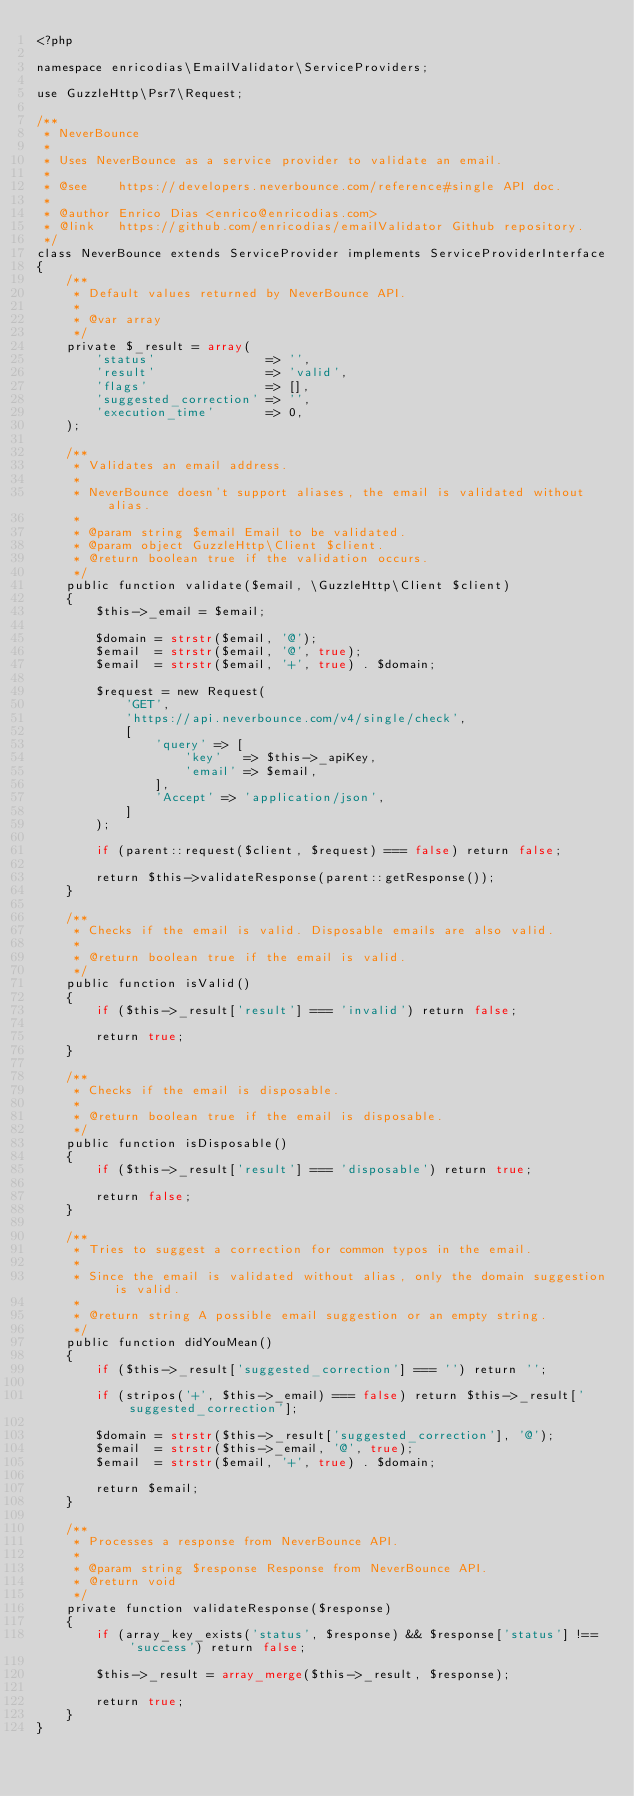<code> <loc_0><loc_0><loc_500><loc_500><_PHP_><?php

namespace enricodias\EmailValidator\ServiceProviders;

use GuzzleHttp\Psr7\Request;

/**
 * NeverBounce
 * 
 * Uses NeverBounce as a service provider to validate an email.
 * 
 * @see    https://developers.neverbounce.com/reference#single API doc.
 * 
 * @author Enrico Dias <enrico@enricodias.com>
 * @link   https://github.com/enricodias/emailValidator Github repository.
 */
class NeverBounce extends ServiceProvider implements ServiceProviderInterface
{
    /**
     * Default values returned by NeverBounce API.
     *
     * @var array
     */
    private $_result = array(
        'status'               => '',
        'result'               => 'valid',
        'flags'                => [],
        'suggested_correction' => '',   
        'execution_time'       => 0,
    );

    /**
     * Validates an email address.
     *
     * NeverBounce doesn't support aliases, the email is validated without alias.
     * 
     * @param string $email Email to be validated.
     * @param object GuzzleHttp\Client $client.
     * @return boolean true if the validation occurs.
     */
    public function validate($email, \GuzzleHttp\Client $client)
    {
        $this->_email = $email;

        $domain = strstr($email, '@');
        $email  = strstr($email, '@', true);
        $email  = strstr($email, '+', true) . $domain;

        $request = new Request(
            'GET',
            'https://api.neverbounce.com/v4/single/check',
            [
                'query' => [
                    'key'   => $this->_apiKey,
                    'email' => $email,
                ],
                'Accept' => 'application/json',
            ]
        );

        if (parent::request($client, $request) === false) return false;

        return $this->validateResponse(parent::getResponse());
    }

    /**
     * Checks if the email is valid. Disposable emails are also valid.
     *
     * @return boolean true if the email is valid.
     */
    public function isValid()
    {
        if ($this->_result['result'] === 'invalid') return false;

        return true;
    }
    
    /**
     * Checks if the email is disposable.
     *
     * @return boolean true if the email is disposable.
     */
    public function isDisposable()
    {
        if ($this->_result['result'] === 'disposable') return true;

        return false;
    }

    /**
     * Tries to suggest a correction for common typos in the email.
     * 
     * Since the email is validated without alias, only the domain suggestion is valid.
     *
     * @return string A possible email suggestion or an empty string.
     */
    public function didYouMean()
    {
        if ($this->_result['suggested_correction'] === '') return '';

        if (stripos('+', $this->_email) === false) return $this->_result['suggested_correction'];

        $domain = strstr($this->_result['suggested_correction'], '@');
        $email  = strstr($this->_email, '@', true);
        $email  = strstr($email, '+', true) . $domain;

        return $email;
    }

    /**
     * Processes a response from NeverBounce API.
     *
     * @param string $response Response from NeverBounce API.
     * @return void
     */
    private function validateResponse($response)
    {
        if (array_key_exists('status', $response) && $response['status'] !== 'success') return false;

        $this->_result = array_merge($this->_result, $response);

        return true;
    }
}</code> 